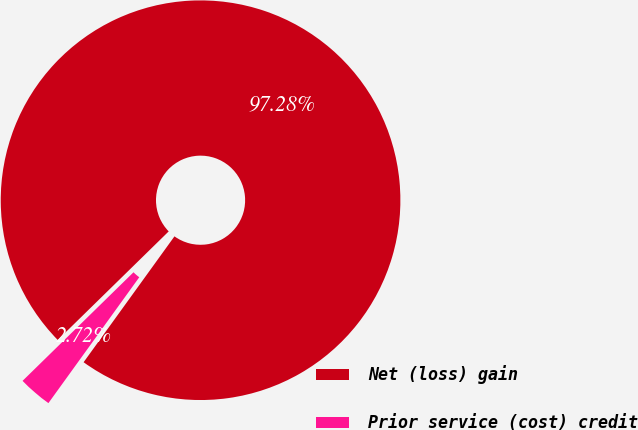Convert chart. <chart><loc_0><loc_0><loc_500><loc_500><pie_chart><fcel>Net (loss) gain<fcel>Prior service (cost) credit<nl><fcel>97.28%<fcel>2.72%<nl></chart> 